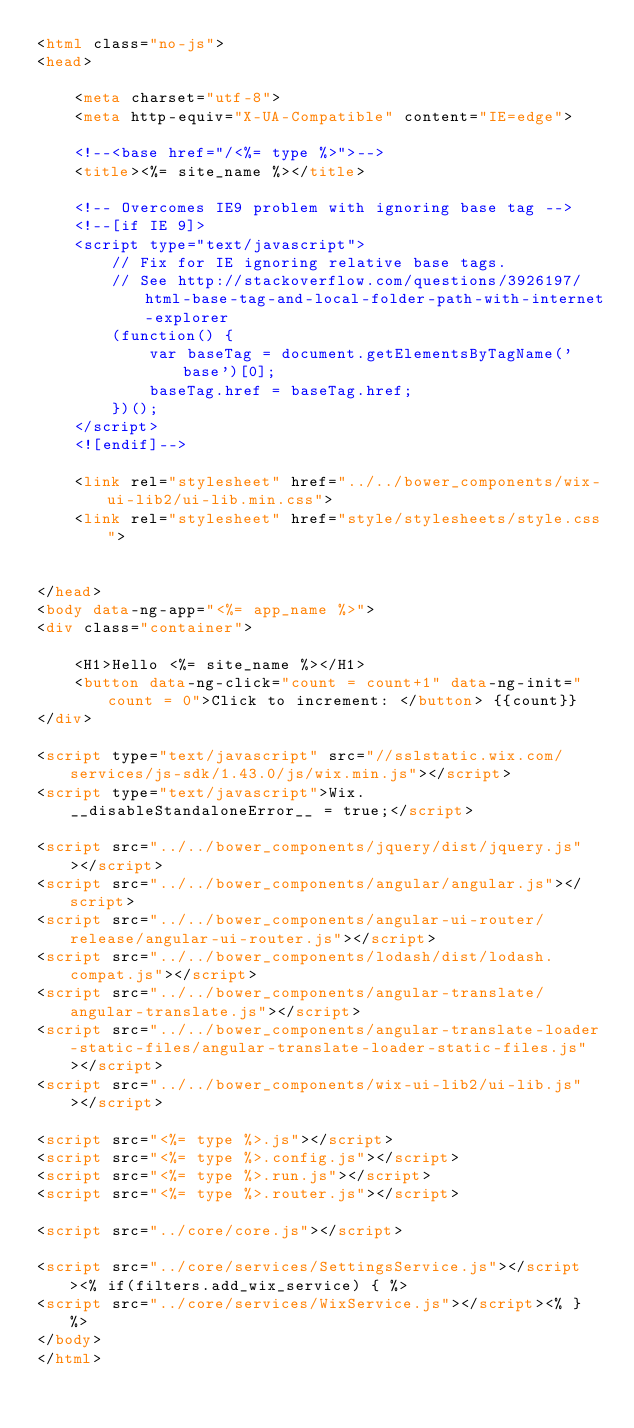Convert code to text. <code><loc_0><loc_0><loc_500><loc_500><_HTML_><html class="no-js">
<head>

    <meta charset="utf-8">
    <meta http-equiv="X-UA-Compatible" content="IE=edge">

    <!--<base href="/<%= type %>">-->
    <title><%= site_name %></title>

    <!-- Overcomes IE9 problem with ignoring base tag -->
    <!--[if IE 9]>
    <script type="text/javascript">
        // Fix for IE ignoring relative base tags.
        // See http://stackoverflow.com/questions/3926197/html-base-tag-and-local-folder-path-with-internet-explorer
        (function() {
            var baseTag = document.getElementsByTagName('base')[0];
            baseTag.href = baseTag.href;
        })();
    </script>
    <![endif]-->

    <link rel="stylesheet" href="../../bower_components/wix-ui-lib2/ui-lib.min.css">
    <link rel="stylesheet" href="style/stylesheets/style.css">


</head>
<body data-ng-app="<%= app_name %>">
<div class="container">

    <H1>Hello <%= site_name %></H1>
    <button data-ng-click="count = count+1" data-ng-init="count = 0">Click to increment: </button> {{count}}
</div>

<script type="text/javascript" src="//sslstatic.wix.com/services/js-sdk/1.43.0/js/wix.min.js"></script>
<script type="text/javascript">Wix.__disableStandaloneError__ = true;</script>

<script src="../../bower_components/jquery/dist/jquery.js"></script>
<script src="../../bower_components/angular/angular.js"></script>
<script src="../../bower_components/angular-ui-router/release/angular-ui-router.js"></script>
<script src="../../bower_components/lodash/dist/lodash.compat.js"></script>
<script src="../../bower_components/angular-translate/angular-translate.js"></script>
<script src="../../bower_components/angular-translate-loader-static-files/angular-translate-loader-static-files.js"></script>
<script src="../../bower_components/wix-ui-lib2/ui-lib.js"></script>

<script src="<%= type %>.js"></script>
<script src="<%= type %>.config.js"></script>
<script src="<%= type %>.run.js"></script>
<script src="<%= type %>.router.js"></script>

<script src="../core/core.js"></script>

<script src="../core/services/SettingsService.js"></script><% if(filters.add_wix_service) { %>
<script src="../core/services/WixService.js"></script><% } %>
</body>
</html></code> 